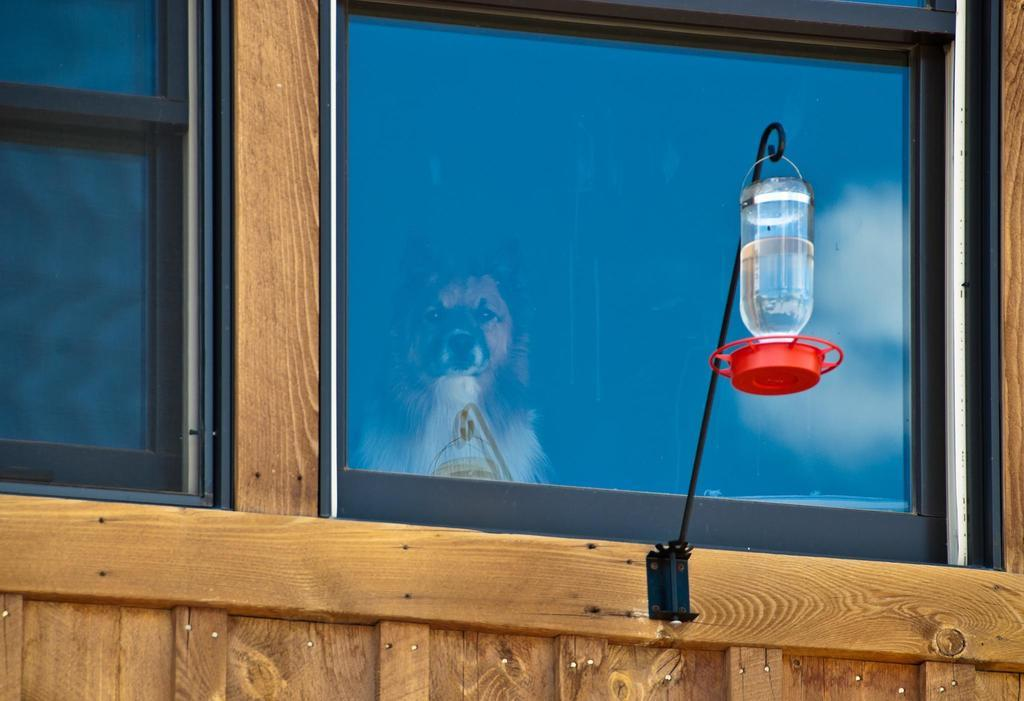What type of openings can be seen in the image? There are windows in the image. What is the source of illumination in the image? There is light in the image. What type of structure is present in the image? There is a wall in the image. What material is used for the windows in the image? There is glass in the image. What animal can be seen through the glass? A dog is visible through the glass. Where is the glove located in the image? There is no glove present in the image. What type of device is used to cool the room in the image? There is no fan present in the image. What type of plant can be seen growing through the wall in the image? There is no root or plant growing through the wall in the image. 